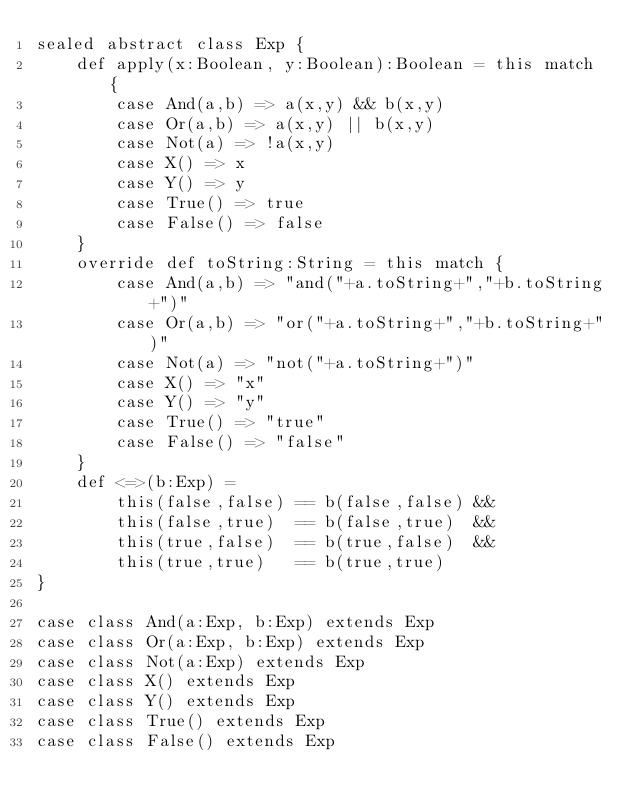Convert code to text. <code><loc_0><loc_0><loc_500><loc_500><_Scala_>sealed abstract class Exp {
    def apply(x:Boolean, y:Boolean):Boolean = this match {
        case And(a,b) => a(x,y) && b(x,y)
        case Or(a,b) => a(x,y) || b(x,y)
        case Not(a) => !a(x,y)
        case X() => x
        case Y() => y
        case True() => true
        case False() => false
    }
    override def toString:String = this match {
        case And(a,b) => "and("+a.toString+","+b.toString+")"
        case Or(a,b) => "or("+a.toString+","+b.toString+")"
        case Not(a) => "not("+a.toString+")"
        case X() => "x"
        case Y() => "y"
        case True() => "true"
        case False() => "false"
    }
    def <=>(b:Exp) =
        this(false,false) == b(false,false) &&
        this(false,true)  == b(false,true)  &&
        this(true,false)  == b(true,false)  &&
        this(true,true)   == b(true,true)
}

case class And(a:Exp, b:Exp) extends Exp
case class Or(a:Exp, b:Exp) extends Exp
case class Not(a:Exp) extends Exp
case class X() extends Exp
case class Y() extends Exp
case class True() extends Exp
case class False() extends Exp
</code> 